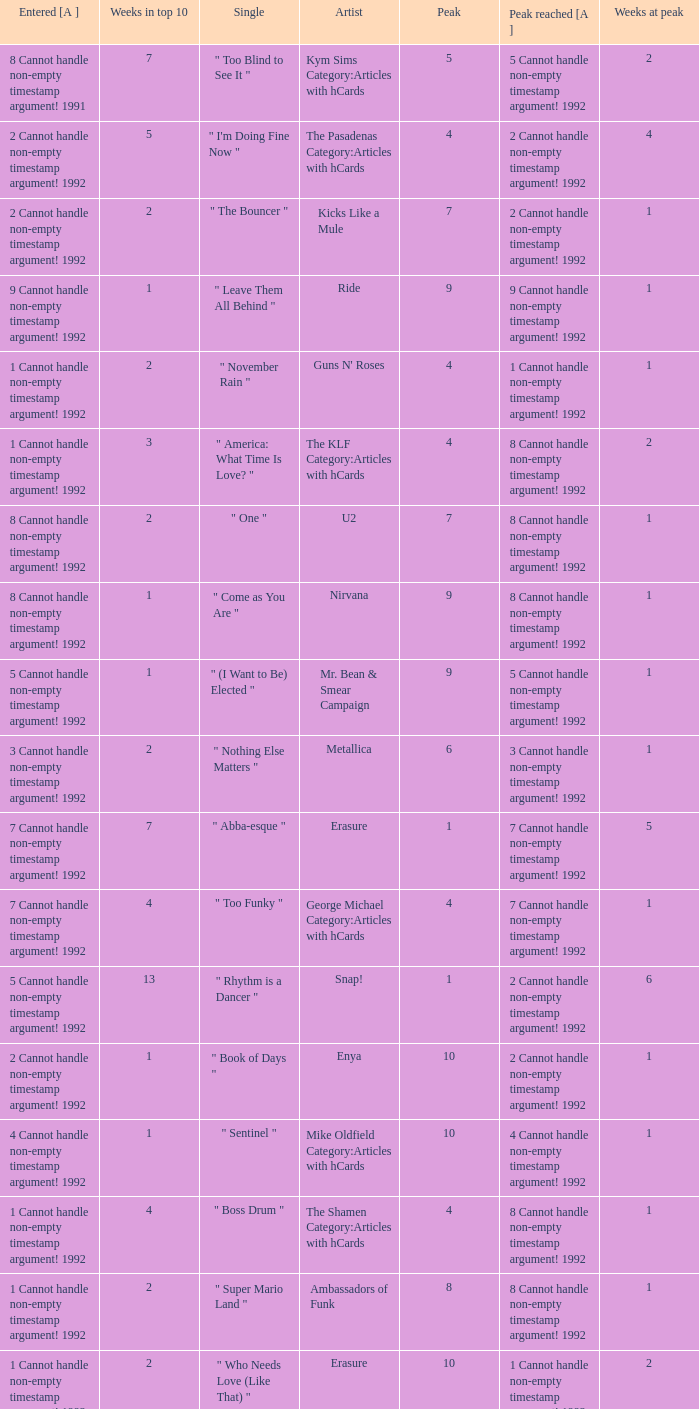If the peak reached is 6 cannot handle non-empty timestamp argument! 1992, what is the entered? 6 Cannot handle non-empty timestamp argument! 1992. 